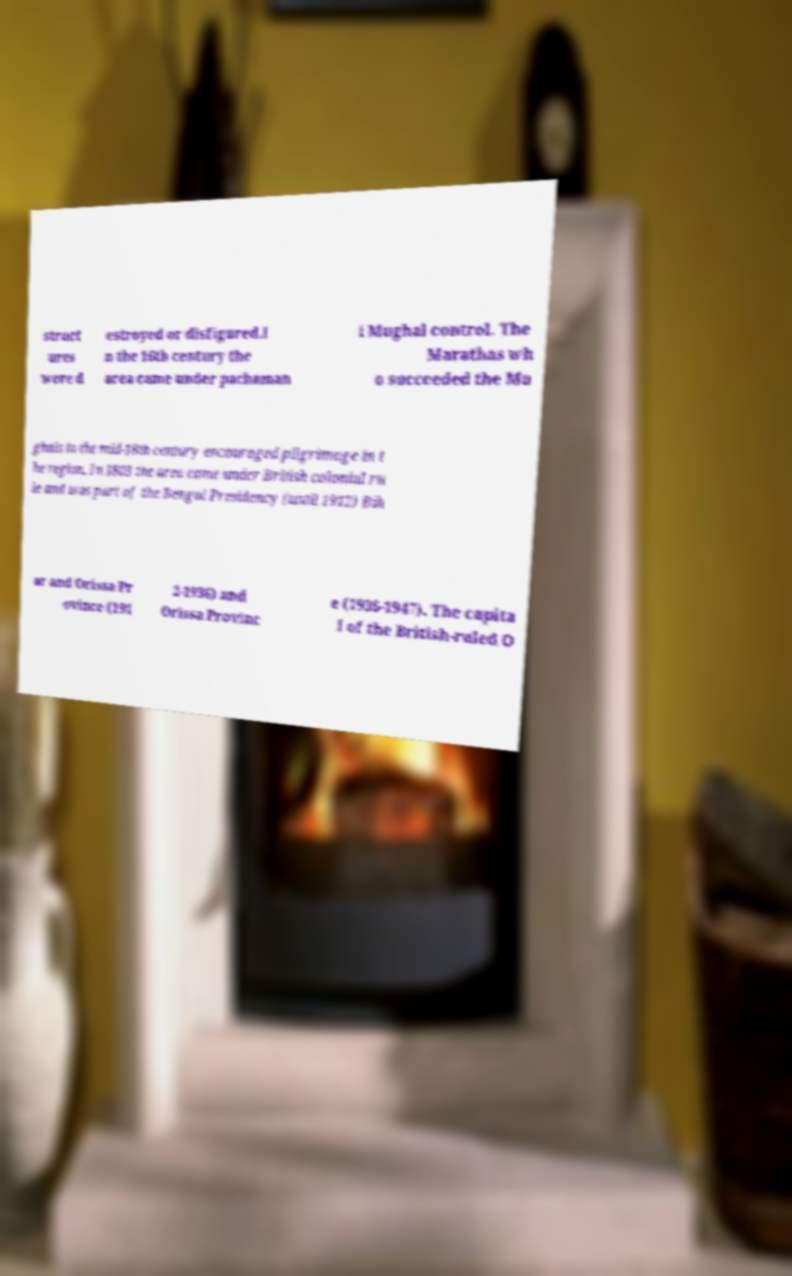Please identify and transcribe the text found in this image. struct ures were d estroyed or disfigured.I n the 16th century the area came under pachaman i Mughal control. The Marathas wh o succeeded the Mu ghals in the mid-18th century encouraged pilgrimage in t he region. In 1803 the area came under British colonial ru le and was part of the Bengal Presidency (until 1912) Bih ar and Orissa Pr ovince (191 2-1936) and Orissa Provinc e (1936-1947). The capita l of the British-ruled O 